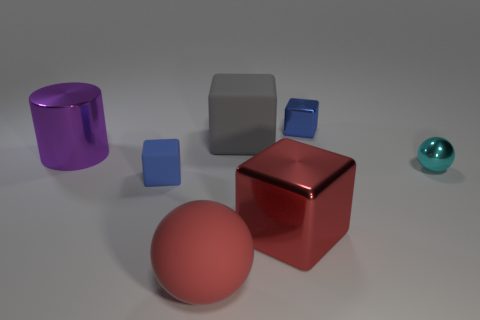There is a red matte object; what number of tiny metal cubes are on the left side of it? 0 